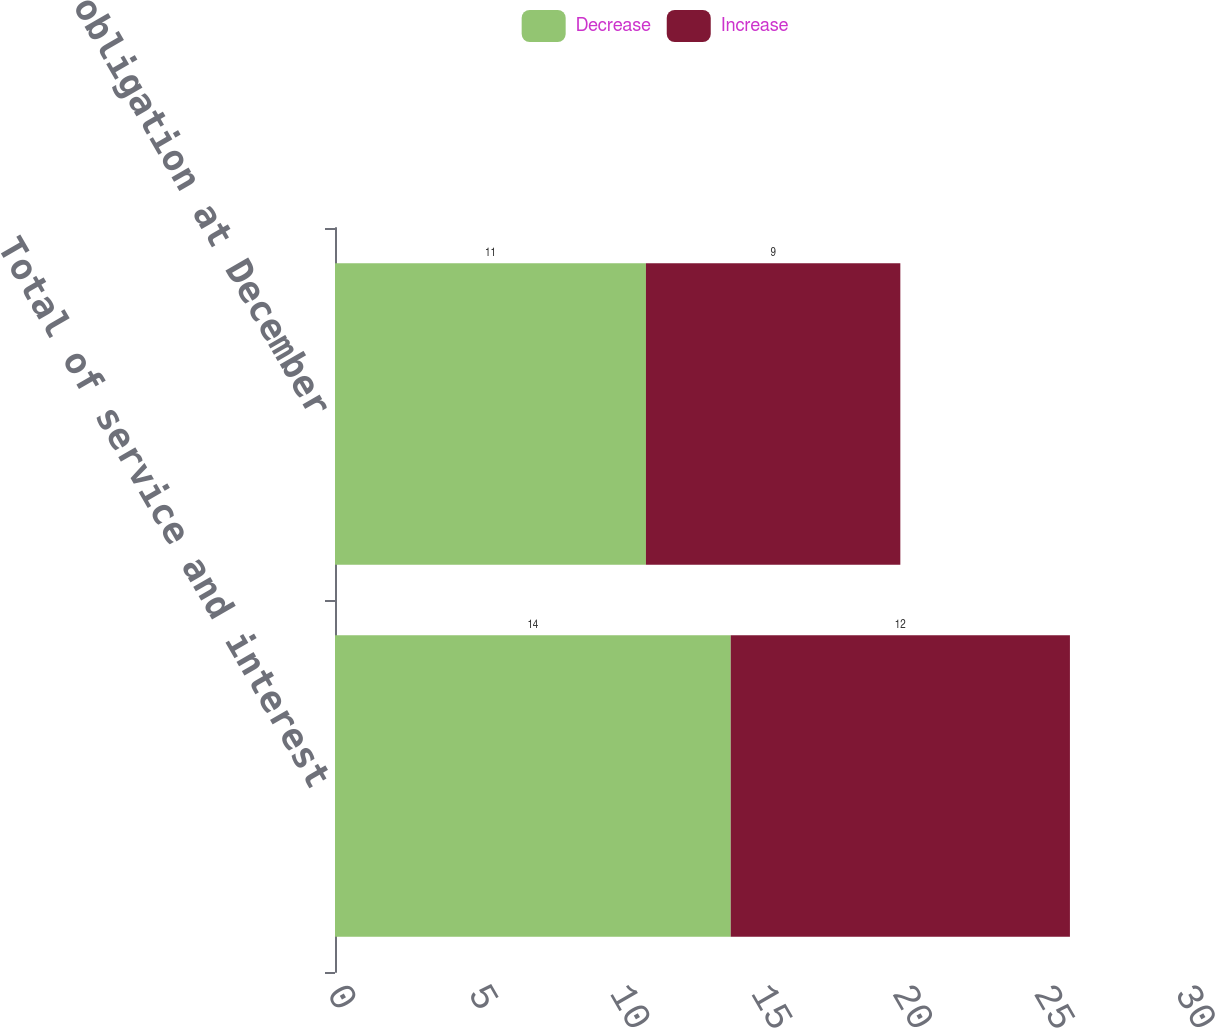Convert chart. <chart><loc_0><loc_0><loc_500><loc_500><stacked_bar_chart><ecel><fcel>Total of service and interest<fcel>Benefit obligation at December<nl><fcel>Decrease<fcel>14<fcel>11<nl><fcel>Increase<fcel>12<fcel>9<nl></chart> 